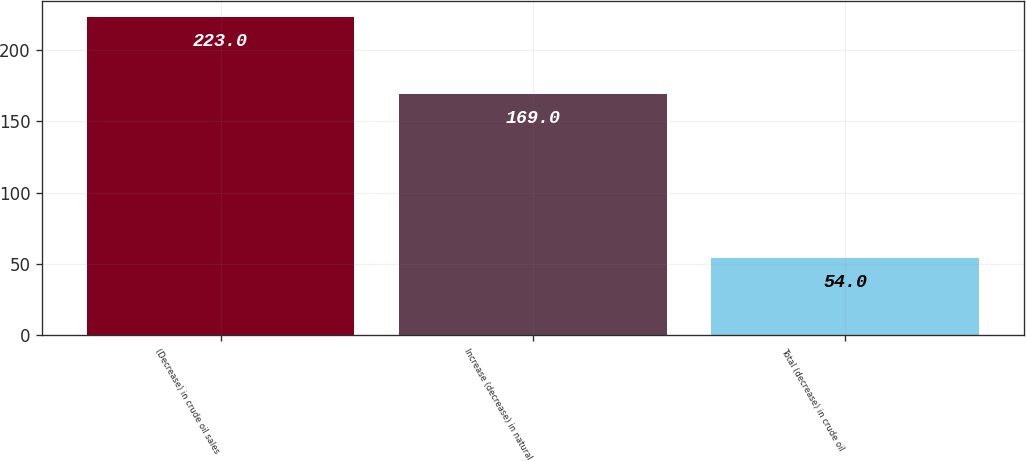Convert chart. <chart><loc_0><loc_0><loc_500><loc_500><bar_chart><fcel>(Decrease) in crude oil sales<fcel>Increase (decrease) in natural<fcel>Total (decrease) in crude oil<nl><fcel>223<fcel>169<fcel>54<nl></chart> 